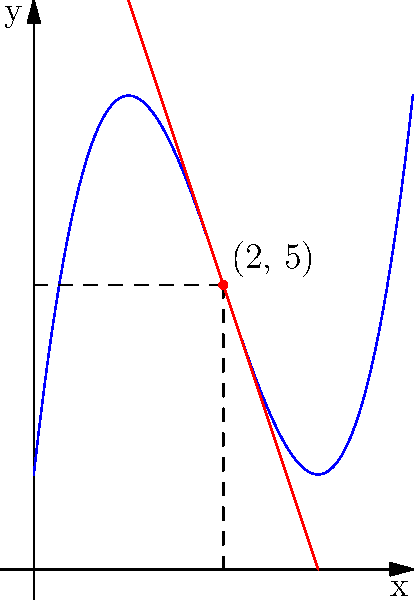In a Finnish-themed video game level inspired by the sauna culture, player progress is modeled by the function $f(x) = x^3 - 6x^2 + 9x + 1$, where $x$ represents the time spent in the level (in minutes) and $f(x)$ represents the player's score. Find the equation of the tangent line to this curve at the point where the player has spent 2 minutes in the level. To find the equation of the tangent line, we need to follow these steps:

1) First, we need to find the coordinates of the point where the player has spent 2 minutes. Let's call this point $(x_0, y_0)$.
   $x_0 = 2$
   $y_0 = f(2) = 2^3 - 6(2^2) + 9(2) + 1 = 8 - 24 + 18 + 1 = 5$
   So, the point is $(2, 5)$

2) Next, we need to find the slope of the tangent line at this point. The slope is given by the derivative of $f(x)$ at $x = 2$.

3) Let's find $f'(x)$:
   $f'(x) = 3x^2 - 12x + 9$

4) Now, we calculate $f'(2)$:
   $f'(2) = 3(2^2) - 12(2) + 9 = 12 - 24 + 9 = -3$

5) We now have a point $(2, 5)$ and a slope $-3$. We can use the point-slope form of a line:
   $y - y_0 = m(x - x_0)$
   Where $(x_0, y_0)$ is our point and $m$ is our slope.

6) Plugging in our values:
   $y - 5 = -3(x - 2)$

7) This is the equation of our tangent line. If we want to express it in slope-intercept form $(y = mx + b)$, we can expand:
   $y - 5 = -3x + 6$
   $y = -3x + 11$

Therefore, the equation of the tangent line is $y = -3x + 11$.
Answer: $y = -3x + 11$ 